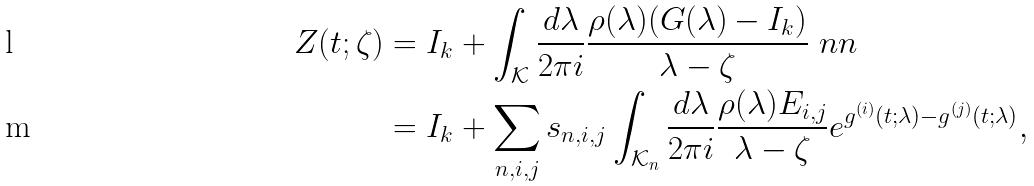Convert formula to latex. <formula><loc_0><loc_0><loc_500><loc_500>Z ( t ; \zeta ) & = I _ { k } + \int _ { \mathcal { K } } \frac { d \lambda } { 2 \pi i } \frac { \rho ( \lambda ) ( G ( \lambda ) - I _ { k } ) } { \lambda - \zeta } \ n n \\ & = I _ { k } + \sum _ { n , i , j } s _ { n , i , j } \int _ { \mathcal { K } _ { n } } \frac { d \lambda } { 2 \pi i } \frac { \rho ( \lambda ) E _ { i , j } } { \lambda - \zeta } e ^ { g ^ { ( i ) } ( t ; \lambda ) - g ^ { ( j ) } ( t ; \lambda ) } ,</formula> 